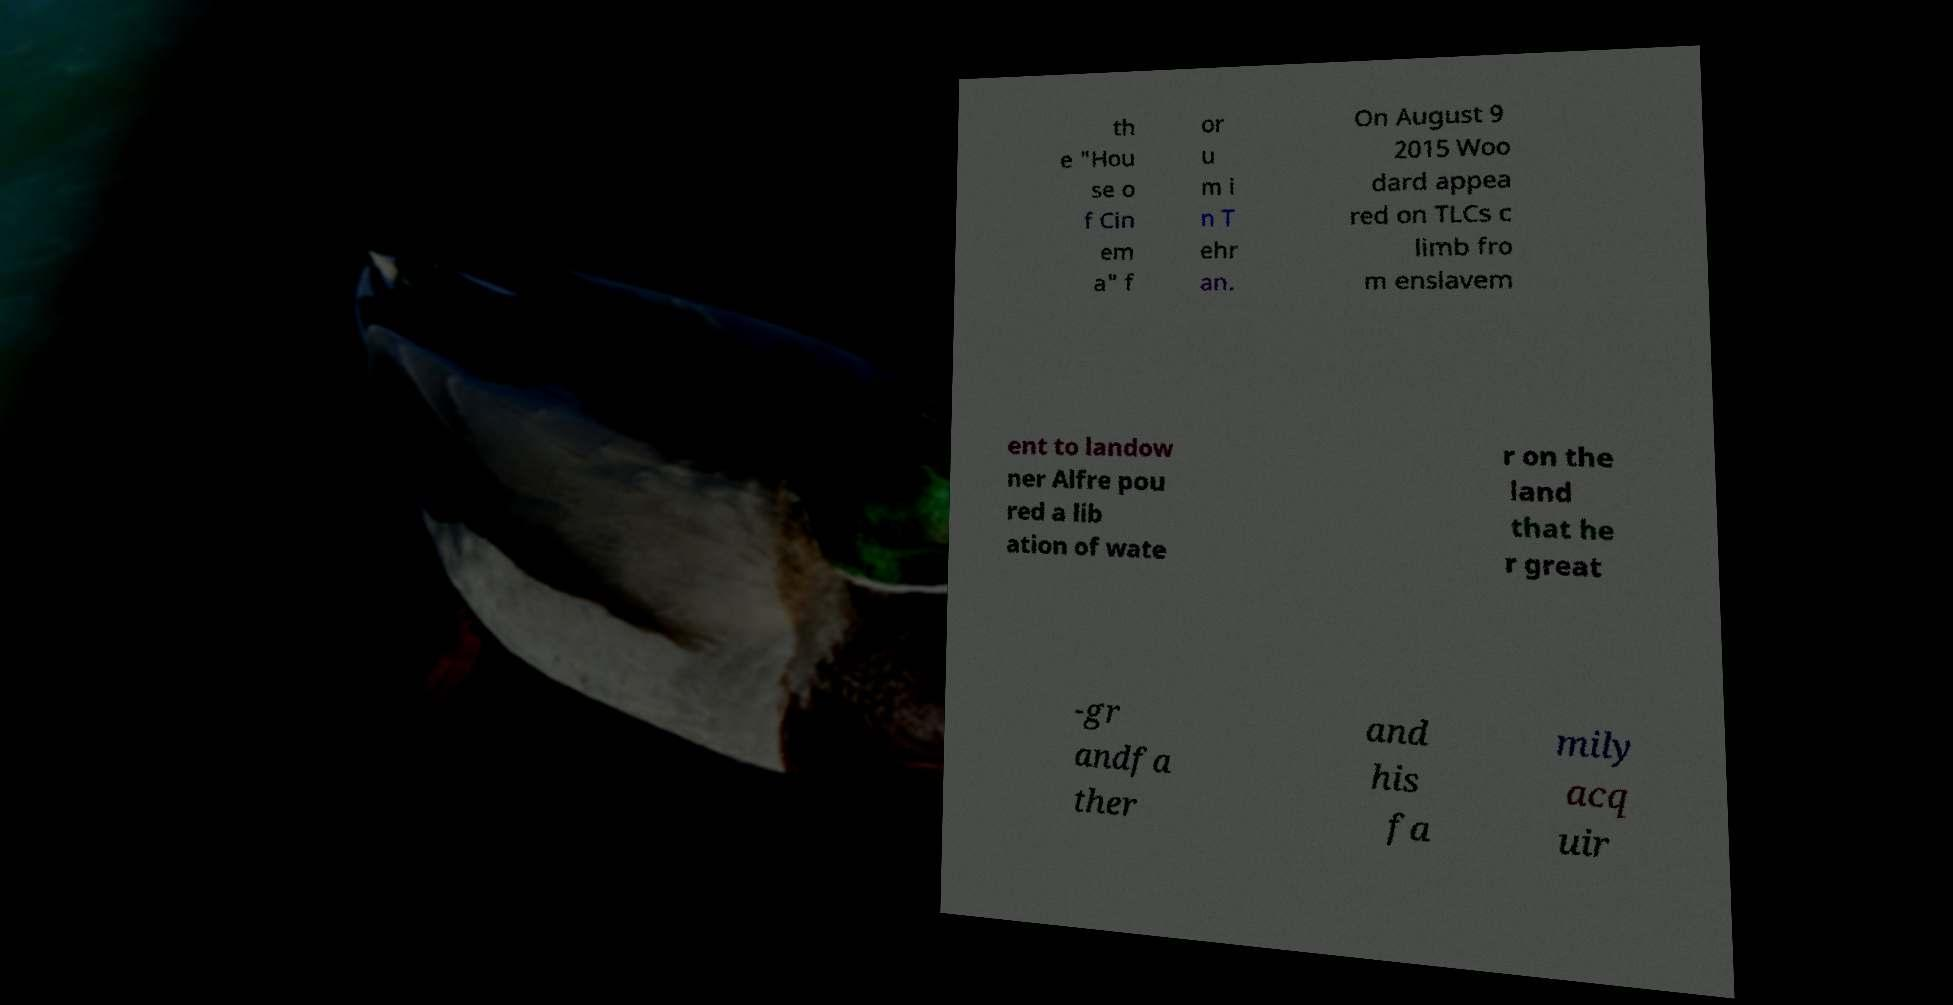There's text embedded in this image that I need extracted. Can you transcribe it verbatim? th e "Hou se o f Cin em a" f or u m i n T ehr an. On August 9 2015 Woo dard appea red on TLCs c limb fro m enslavem ent to landow ner Alfre pou red a lib ation of wate r on the land that he r great -gr andfa ther and his fa mily acq uir 